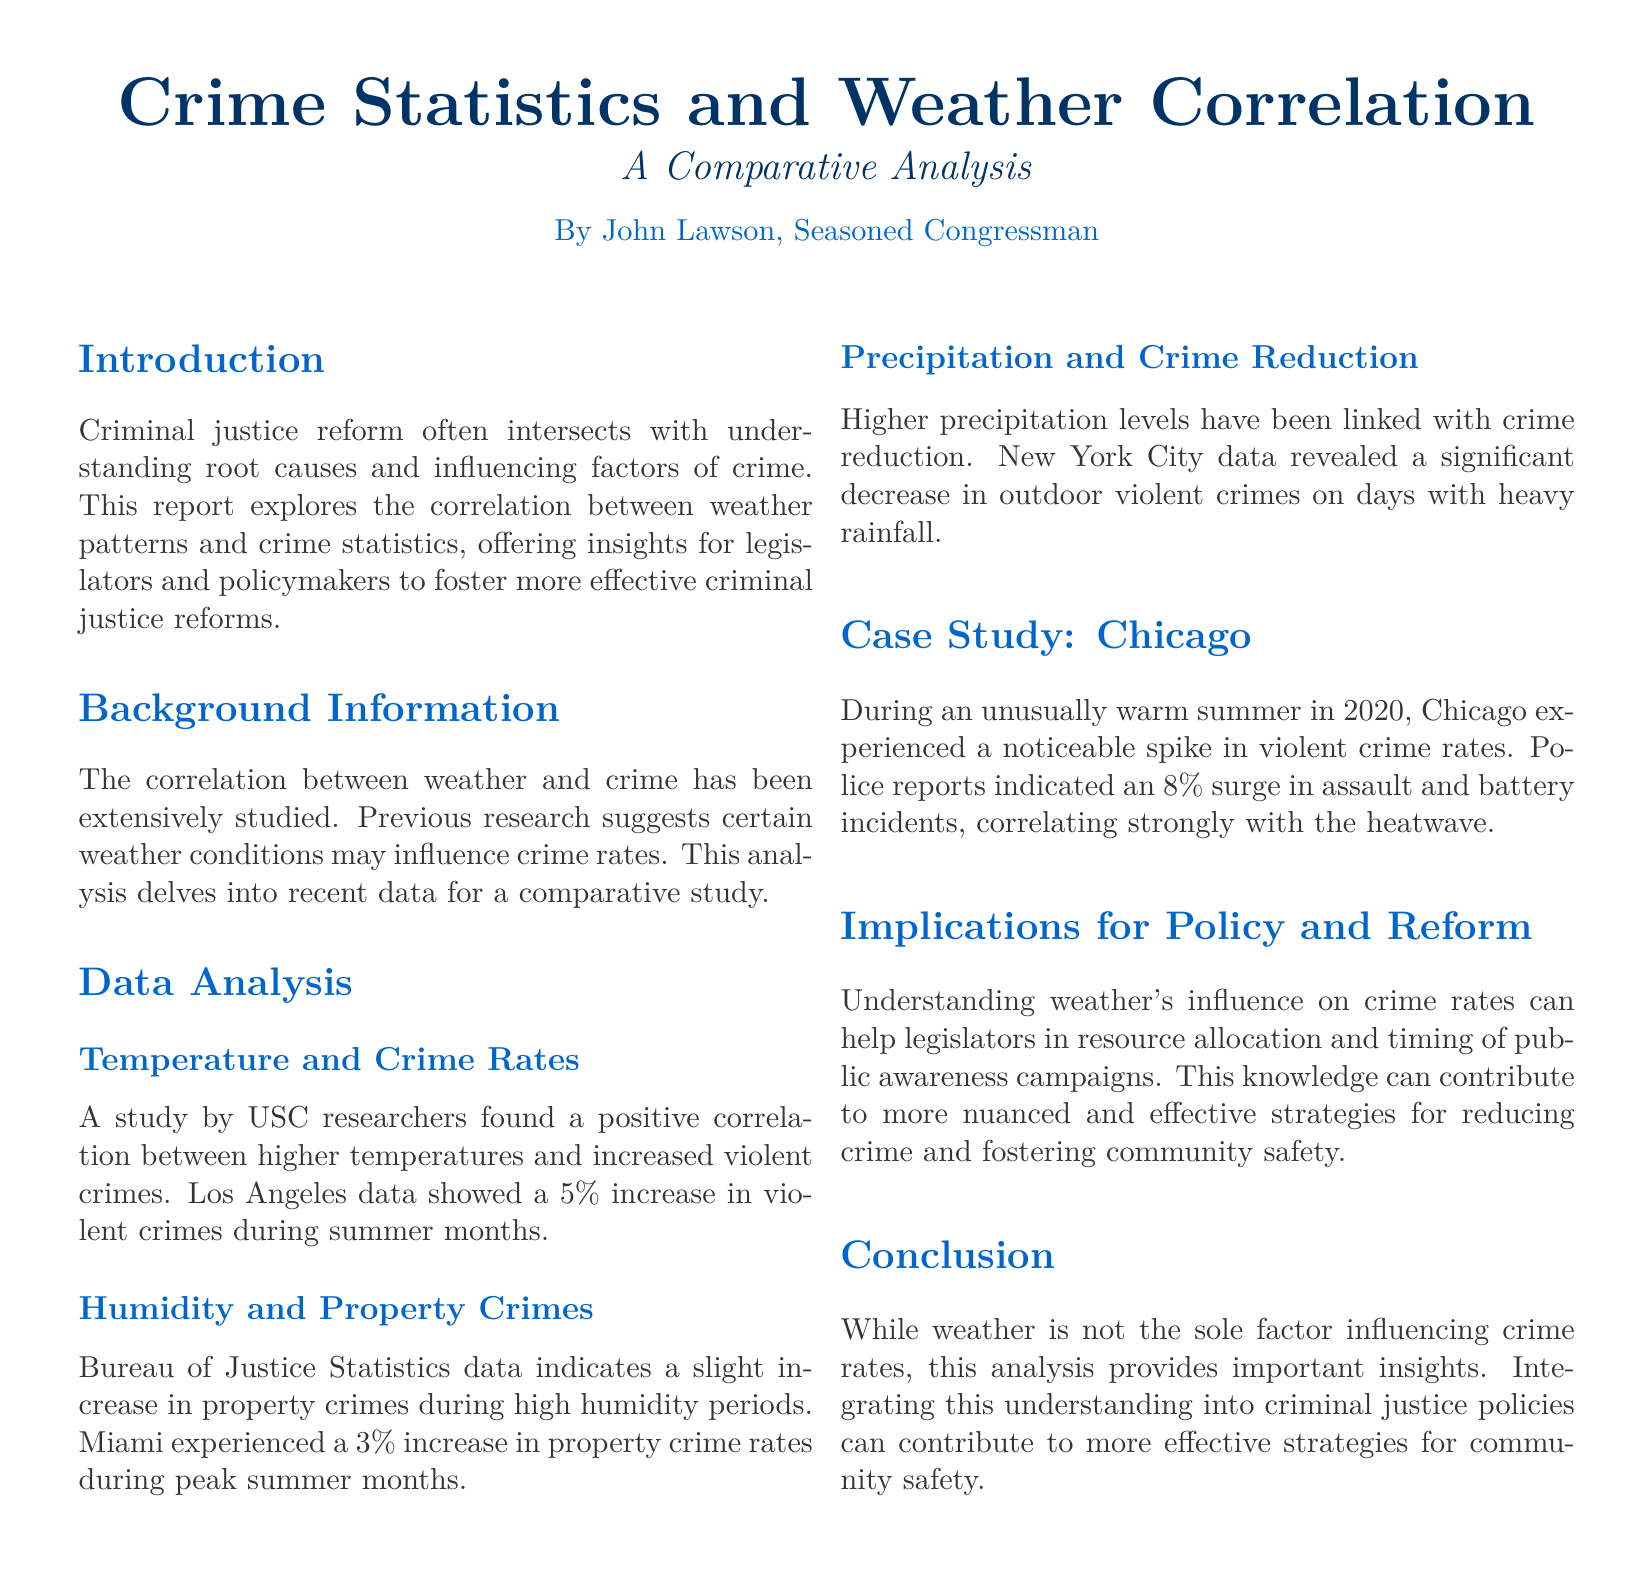What is the title of the report? The title of the report is mentioned prominently at the beginning of the document.
Answer: Crime Statistics and Weather Correlation Who is the author of the report? The author is identified in the introduction section of the document.
Answer: John Lawson What increase in violent crimes was noted during the summer months in Los Angeles? The document provides specific statistics related to crime increases during certain temperature conditions.
Answer: 5% In which city was a 3% increase in property crimes observed? The city where this property crime increase was reported is mentioned in the humidity data analysis.
Answer: Miami What was the percentage surge in assault and battery incidents in Chicago during the warm summer of 2020? The document specifies the exact percentage increase in crime for this case study.
Answer: 8% What effect does higher precipitation have on outdoor violent crimes, according to the report? The document discusses the impact of weather conditions on crimes, specifically precipitation's effect.
Answer: Reduction What is the main implication of understanding weather's influence on crime rates? This question seeks to understand the broader context and application of the findings presented in the document.
Answer: Resource allocation What is the publication format of this document? The structure and formatting used in the document can help identify its type.
Answer: Report 